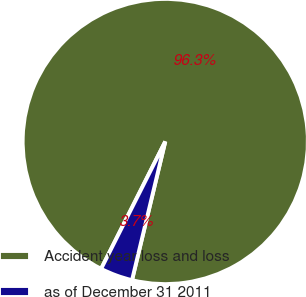Convert chart to OTSL. <chart><loc_0><loc_0><loc_500><loc_500><pie_chart><fcel>Accident year loss and loss<fcel>as of December 31 2011<nl><fcel>96.32%<fcel>3.68%<nl></chart> 